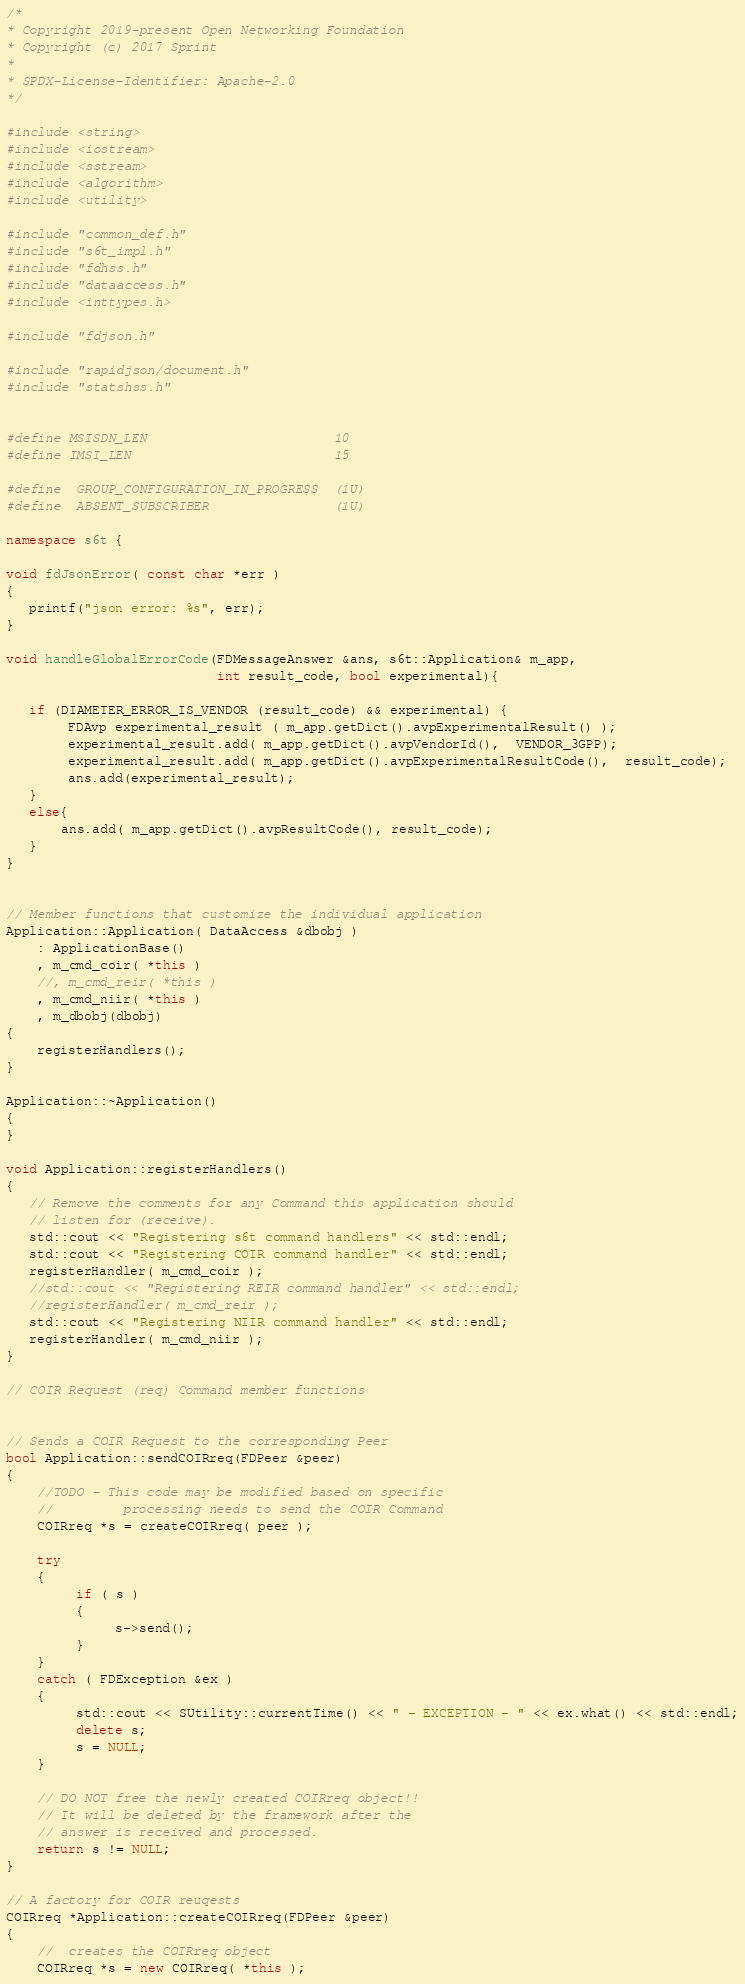<code> <loc_0><loc_0><loc_500><loc_500><_C++_>/*
* Copyright 2019-present Open Networking Foundation
* Copyright (c) 2017 Sprint
*
* SPDX-License-Identifier: Apache-2.0
*/

#include <string>
#include <iostream>
#include <sstream>
#include <algorithm>
#include <utility>

#include "common_def.h"
#include "s6t_impl.h"
#include "fdhss.h"
#include "dataaccess.h"
#include <inttypes.h>

#include "fdjson.h"

#include "rapidjson/document.h"
#include "statshss.h"


#define MSISDN_LEN                        10
#define IMSI_LEN                          15

#define  GROUP_CONFIGURATION_IN_PROGRESS  (1U)
#define  ABSENT_SUBSCRIBER                (1U)

namespace s6t {

void fdJsonError( const char *err )
{
   printf("json error: %s", err);
}

void handleGlobalErrorCode(FDMessageAnswer &ans, s6t::Application& m_app,
                           int result_code, bool experimental){

   if (DIAMETER_ERROR_IS_VENDOR (result_code) && experimental) {
        FDAvp experimental_result ( m_app.getDict().avpExperimentalResult() );
        experimental_result.add( m_app.getDict().avpVendorId(),  VENDOR_3GPP);
        experimental_result.add( m_app.getDict().avpExperimentalResultCode(),  result_code);
        ans.add(experimental_result);
   }
   else{
       ans.add( m_app.getDict().avpResultCode(), result_code);
   }
}


// Member functions that customize the individual application
Application::Application( DataAccess &dbobj )
    : ApplicationBase()
    , m_cmd_coir( *this )
    //, m_cmd_reir( *this )
    , m_cmd_niir( *this )
    , m_dbobj(dbobj)
{
    registerHandlers();
}

Application::~Application()
{
}

void Application::registerHandlers()
{
   // Remove the comments for any Command this application should
   // listen for (receive).
   std::cout << "Registering s6t command handlers" << std::endl;
   std::cout << "Registering COIR command handler" << std::endl;
   registerHandler( m_cmd_coir );
   //std::cout << "Registering REIR command handler" << std::endl;
   //registerHandler( m_cmd_reir );
   std::cout << "Registering NIIR command handler" << std::endl;
   registerHandler( m_cmd_niir );
}

// COIR Request (req) Command member functions


// Sends a COIR Request to the corresponding Peer
bool Application::sendCOIRreq(FDPeer &peer)
{
    //TODO - This code may be modified based on specific
    //         processing needs to send the COIR Command
    COIRreq *s = createCOIRreq( peer );

    try
    {
         if ( s )
         {
              s->send();
         }
    }
    catch ( FDException &ex )
    {
         std::cout << SUtility::currentTime() << " - EXCEPTION - " << ex.what() << std::endl;
         delete s;
         s = NULL;
    }

    // DO NOT free the newly created COIRreq object!!
    // It will be deleted by the framework after the
    // answer is received and processed.
    return s != NULL;
}

// A factory for COIR reuqests
COIRreq *Application::createCOIRreq(FDPeer &peer)
{
    //  creates the COIRreq object
    COIRreq *s = new COIRreq( *this );
</code> 